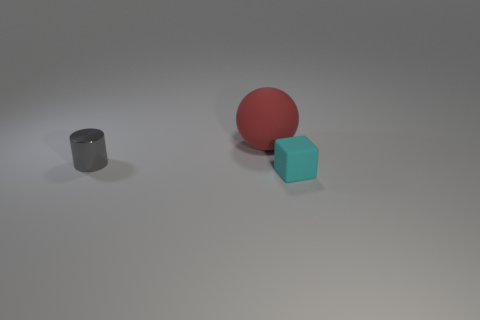How many blocks are either cyan objects or brown rubber objects?
Keep it short and to the point. 1. What color is the big object that is made of the same material as the tiny cyan cube?
Your answer should be very brief. Red. Are the red sphere and the thing that is on the left side of the big red matte thing made of the same material?
Keep it short and to the point. No. What number of objects are either brown metallic blocks or large matte objects?
Ensure brevity in your answer.  1. There is a small metal object; how many red objects are right of it?
Provide a short and direct response. 1. What is the material of the small thing that is to the left of the tiny thing that is to the right of the red matte thing?
Provide a succinct answer. Metal. What is the material of the gray thing that is the same size as the cyan rubber thing?
Offer a very short reply. Metal. Are there any red objects of the same size as the block?
Make the answer very short. No. There is a object behind the small gray shiny cylinder; what is its color?
Your response must be concise. Red. There is a rubber object that is behind the tiny cyan rubber thing; is there a rubber sphere that is right of it?
Offer a very short reply. No. 